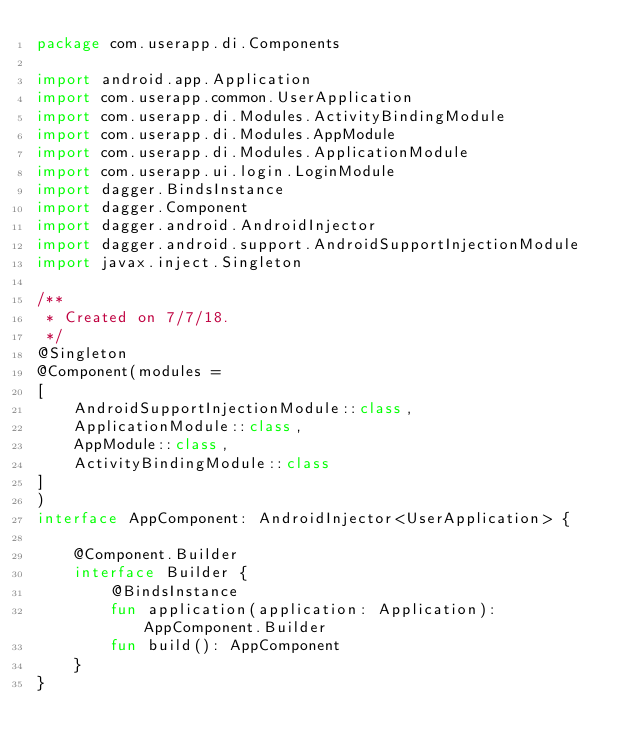Convert code to text. <code><loc_0><loc_0><loc_500><loc_500><_Kotlin_>package com.userapp.di.Components

import android.app.Application
import com.userapp.common.UserApplication
import com.userapp.di.Modules.ActivityBindingModule
import com.userapp.di.Modules.AppModule
import com.userapp.di.Modules.ApplicationModule
import com.userapp.ui.login.LoginModule
import dagger.BindsInstance
import dagger.Component
import dagger.android.AndroidInjector
import dagger.android.support.AndroidSupportInjectionModule
import javax.inject.Singleton

/**
 * Created on 7/7/18.
 */
@Singleton
@Component(modules =
[
    AndroidSupportInjectionModule::class,
    ApplicationModule::class,
    AppModule::class,
    ActivityBindingModule::class
]
)
interface AppComponent: AndroidInjector<UserApplication> {

    @Component.Builder
    interface Builder {
        @BindsInstance
        fun application(application: Application): AppComponent.Builder
        fun build(): AppComponent
    }
}</code> 